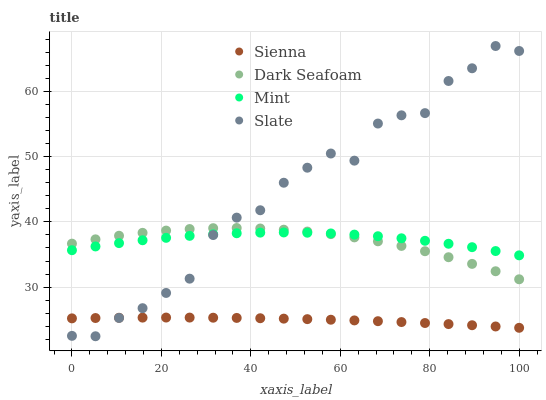Does Sienna have the minimum area under the curve?
Answer yes or no. Yes. Does Slate have the maximum area under the curve?
Answer yes or no. Yes. Does Dark Seafoam have the minimum area under the curve?
Answer yes or no. No. Does Dark Seafoam have the maximum area under the curve?
Answer yes or no. No. Is Sienna the smoothest?
Answer yes or no. Yes. Is Slate the roughest?
Answer yes or no. Yes. Is Dark Seafoam the smoothest?
Answer yes or no. No. Is Dark Seafoam the roughest?
Answer yes or no. No. Does Slate have the lowest value?
Answer yes or no. Yes. Does Dark Seafoam have the lowest value?
Answer yes or no. No. Does Slate have the highest value?
Answer yes or no. Yes. Does Dark Seafoam have the highest value?
Answer yes or no. No. Is Sienna less than Mint?
Answer yes or no. Yes. Is Mint greater than Sienna?
Answer yes or no. Yes. Does Mint intersect Dark Seafoam?
Answer yes or no. Yes. Is Mint less than Dark Seafoam?
Answer yes or no. No. Is Mint greater than Dark Seafoam?
Answer yes or no. No. Does Sienna intersect Mint?
Answer yes or no. No. 